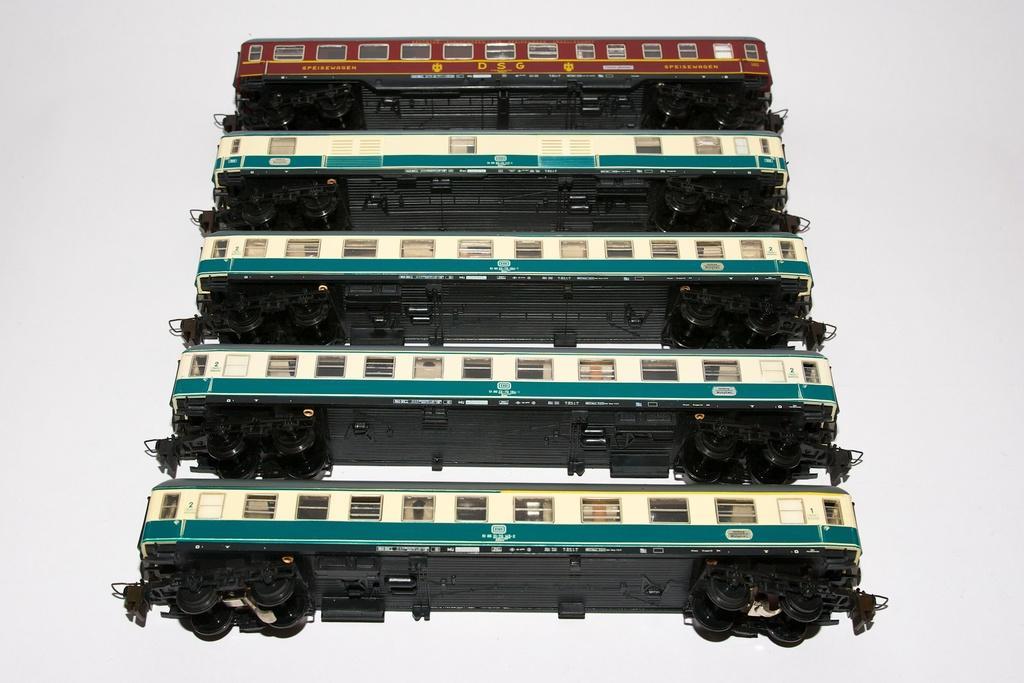How would you summarize this image in a sentence or two? The picture consists of railway compartments. 